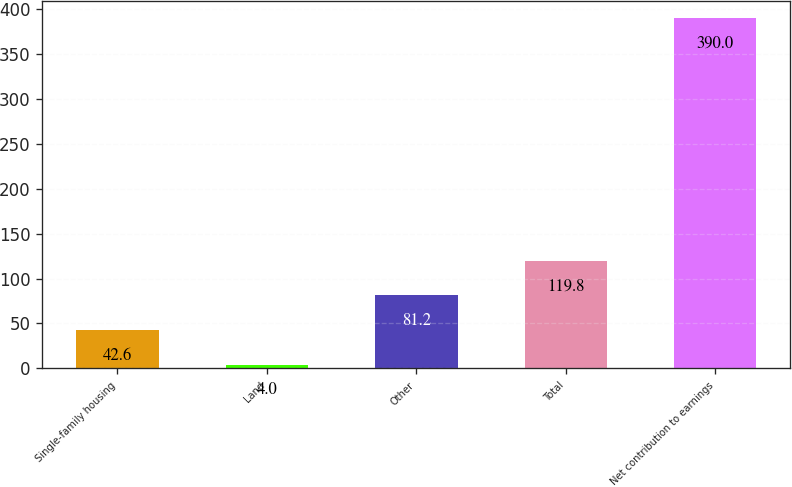<chart> <loc_0><loc_0><loc_500><loc_500><bar_chart><fcel>Single-family housing<fcel>Land<fcel>Other<fcel>Total<fcel>Net contribution to earnings<nl><fcel>42.6<fcel>4<fcel>81.2<fcel>119.8<fcel>390<nl></chart> 